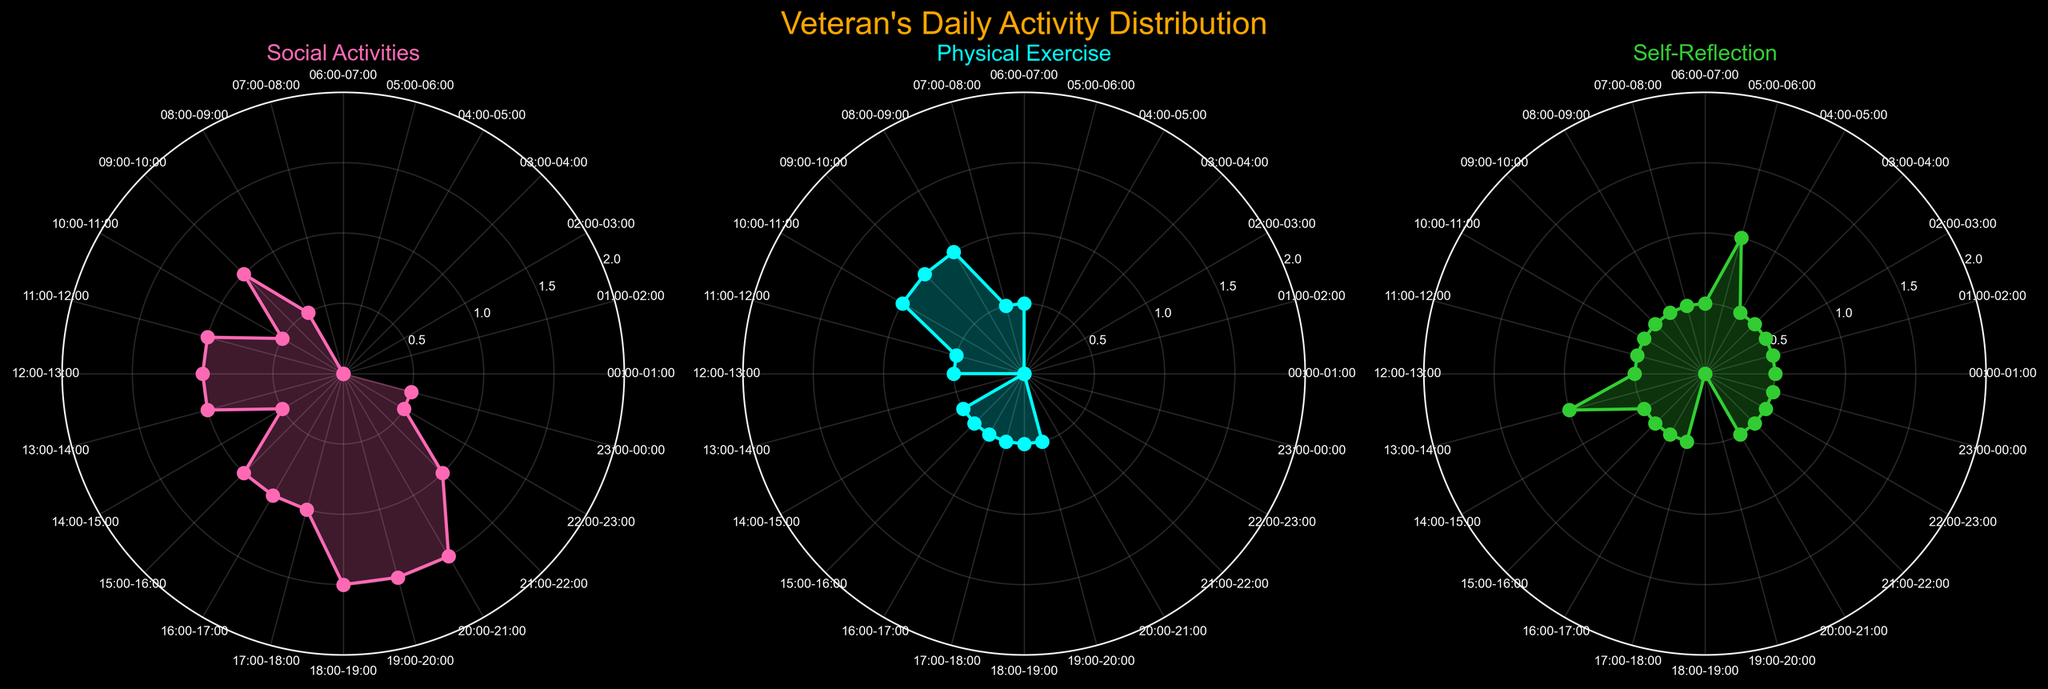What is the title of the figure? The title is usually placed at the top of the figure in a larger font size. By looking at the top, we can see it says "Veteran's Daily Activity Distribution".
Answer: Veteran's Daily Activity Distribution How many subplots are in the figure? The figure consists of three separate polar charts, each representing different activities. We can count the number of subplots to see there are three.
Answer: Three What does the color pink represent in the figure? For each subplot, the legend or color usage can indicate what each color represents. Here, the pink color corresponds to the 'Social Activities' subplot.
Answer: Social Activities During which time intervals does 'Self-Reflection' reach its peak value? By looking at the subplot for 'Self-Reflection', we identify the peak values. The tallest peaks occur from 05:00-06:00 and 13:00-14:00.
Answer: 05:00-06:00, 13:00-14:00 Which activity has the highest value at 09:00-10:00? We examine 09:00-10:00 in all three subplots to determine which activity has the highest value. 'Physical Exercise' and 'Social Activities' both reach their peak of 1 during this interval.
Answer: Physical Exercise and Social Activities What is the average value of 'Social Activities' in the time intervals from 18:00 to 21:00? To find the average, sum the values of 'Social Activities' from 18:00-21:00 (1.5 + 1.5 + 1.5 = 4.5). There are 3 intervals, so the average is 4.5/3 = 1.5
Answer: 1.5 Which activity shows the most variation throughout the day? We identify the extent to which values fluctuate among 'Social Activities', 'Physical Exercise', and 'Self-Reflection'. 'Social Activities' varies between 0 and 1.5, 'Physical Exercise' between 0 and 1, and 'Self-Reflection' shows values of 0, 0.5, and 1. Hence, 'Social Activities' shows the most variation.
Answer: Social Activities During which hours do all three activities show some level of participation? We need to find the time intervals where all three activity values are greater than 0. At 08:00-09:00, 09:00-10:00, and 10:00-11:00, all activities have some participation.
Answer: 08:00-09:00, 09:00-10:00, 10:00-11:00 Which activity sees the most participation from 17:00 to 18:00? We compare the values of each activity from 17:00-18:00. 'Social Activities' stands at 1, 'Physical Exercise' at 0.5, 'Self-Reflection' at 0.5, so 'Social Activities' has the highest value.
Answer: Social Activities How does the distribution of 'Physical Exercise' differ between the morning and evening? Observing the polar chart for 'Physical Exercise', morning times (00:00-12:00) show higher peaks (notably at 08:00-11:00), while evening times (12:00-00:00) show lower overall values with a few peaks.
Answer: Higher in the morning, Lower in the evening 